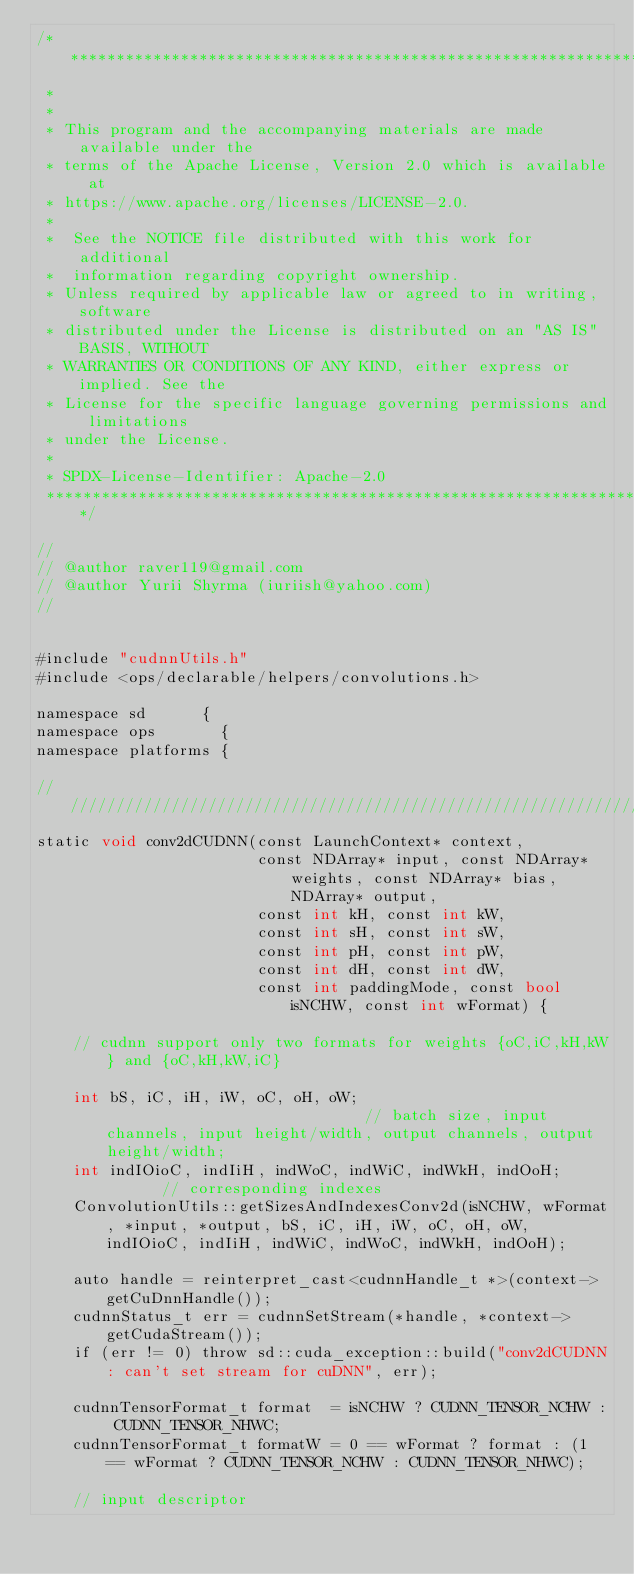<code> <loc_0><loc_0><loc_500><loc_500><_Cuda_>/* ******************************************************************************
 *
 *
 * This program and the accompanying materials are made available under the
 * terms of the Apache License, Version 2.0 which is available at
 * https://www.apache.org/licenses/LICENSE-2.0.
 *
 *  See the NOTICE file distributed with this work for additional
 *  information regarding copyright ownership.
 * Unless required by applicable law or agreed to in writing, software
 * distributed under the License is distributed on an "AS IS" BASIS, WITHOUT
 * WARRANTIES OR CONDITIONS OF ANY KIND, either express or implied. See the
 * License for the specific language governing permissions and limitations
 * under the License.
 *
 * SPDX-License-Identifier: Apache-2.0
 ******************************************************************************/

//
// @author raver119@gmail.com
// @author Yurii Shyrma (iuriish@yahoo.com)
//


#include "cudnnUtils.h"
#include <ops/declarable/helpers/convolutions.h>

namespace sd      {
namespace ops       {
namespace platforms {

//////////////////////////////////////////////////////////////////////////
static void conv2dCUDNN(const LaunchContext* context,
                        const NDArray* input, const NDArray* weights, const NDArray* bias, NDArray* output,
                        const int kH, const int kW,
                        const int sH, const int sW,
                        const int pH, const int pW,
                        const int dH, const int dW,
                        const int paddingMode, const bool isNCHW, const int wFormat) {

    // cudnn support only two formats for weights {oC,iC,kH,kW} and {oC,kH,kW,iC}

    int bS, iC, iH, iW, oC, oH, oW;                             // batch size, input channels, input height/width, output channels, output height/width;
    int indIOioC, indIiH, indWoC, indWiC, indWkH, indOoH;       // corresponding indexes
    ConvolutionUtils::getSizesAndIndexesConv2d(isNCHW, wFormat, *input, *output, bS, iC, iH, iW, oC, oH, oW, indIOioC, indIiH, indWiC, indWoC, indWkH, indOoH);

    auto handle = reinterpret_cast<cudnnHandle_t *>(context->getCuDnnHandle());
    cudnnStatus_t err = cudnnSetStream(*handle, *context->getCudaStream());
    if (err != 0) throw sd::cuda_exception::build("conv2dCUDNN: can't set stream for cuDNN", err);

    cudnnTensorFormat_t format  = isNCHW ? CUDNN_TENSOR_NCHW : CUDNN_TENSOR_NHWC;
    cudnnTensorFormat_t formatW = 0 == wFormat ? format : (1 == wFormat ? CUDNN_TENSOR_NCHW : CUDNN_TENSOR_NHWC);

    // input descriptor</code> 